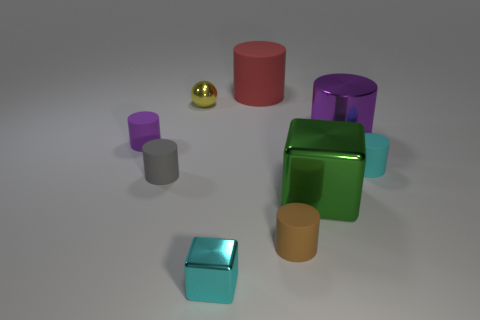There is a small matte thing that is behind the gray cylinder and on the right side of the tiny purple rubber thing; what shape is it?
Provide a succinct answer. Cylinder. Are there an equal number of big shiny cubes that are to the left of the small yellow sphere and tiny brown rubber objects that are on the left side of the small purple matte thing?
Keep it short and to the point. Yes. There is a tiny rubber thing to the right of the metallic cylinder; is its shape the same as the brown rubber thing?
Your response must be concise. Yes. How many yellow objects are large rubber things or small metal things?
Your response must be concise. 1. There is a small cyan object that is the same shape as the red rubber object; what material is it?
Ensure brevity in your answer.  Rubber. There is a object behind the small yellow object; what shape is it?
Provide a succinct answer. Cylinder. Is there a gray cube that has the same material as the tiny purple object?
Your answer should be very brief. No. Is the size of the yellow ball the same as the brown rubber thing?
Your answer should be very brief. Yes. How many spheres are red objects or purple rubber things?
Offer a terse response. 0. There is a tiny cylinder that is the same color as the large shiny cylinder; what material is it?
Keep it short and to the point. Rubber. 